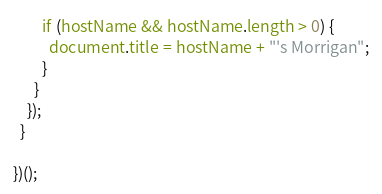Convert code to text. <code><loc_0><loc_0><loc_500><loc_500><_JavaScript_>        if (hostName && hostName.length > 0) {
          document.title = hostName + "'s Morrigan";
        }
      }
    });
  }

})();
</code> 